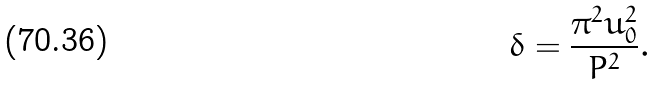<formula> <loc_0><loc_0><loc_500><loc_500>\delta = \frac { { \pi ^ { 2 } u _ { 0 } ^ { 2 } } } { { P ^ { 2 } } } .</formula> 